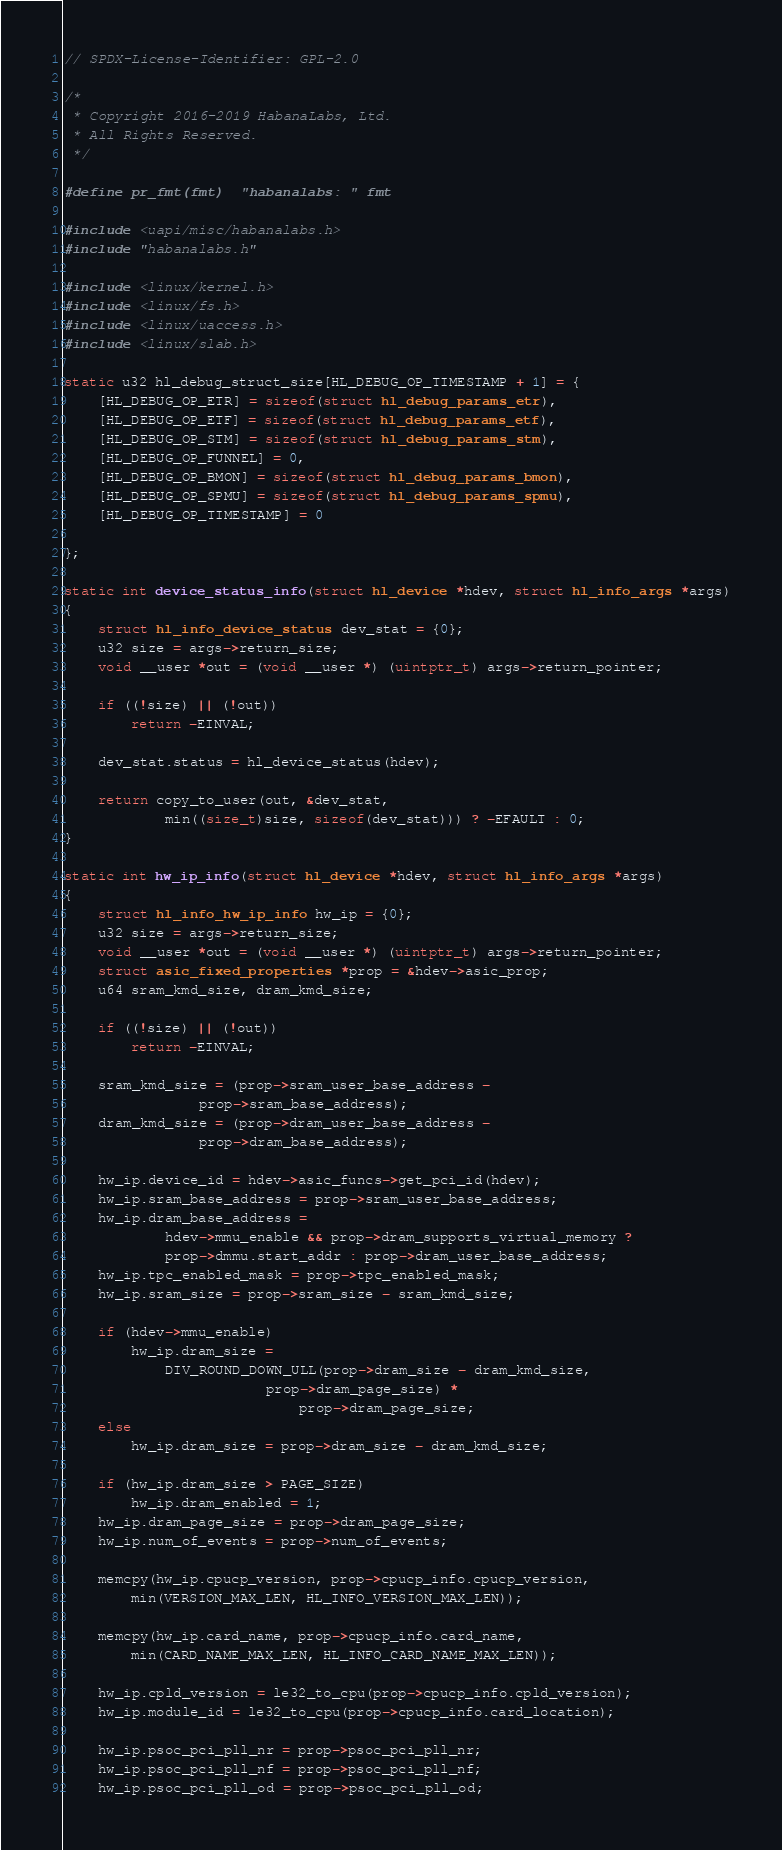<code> <loc_0><loc_0><loc_500><loc_500><_C_>// SPDX-License-Identifier: GPL-2.0

/*
 * Copyright 2016-2019 HabanaLabs, Ltd.
 * All Rights Reserved.
 */

#define pr_fmt(fmt)	"habanalabs: " fmt

#include <uapi/misc/habanalabs.h>
#include "habanalabs.h"

#include <linux/kernel.h>
#include <linux/fs.h>
#include <linux/uaccess.h>
#include <linux/slab.h>

static u32 hl_debug_struct_size[HL_DEBUG_OP_TIMESTAMP + 1] = {
	[HL_DEBUG_OP_ETR] = sizeof(struct hl_debug_params_etr),
	[HL_DEBUG_OP_ETF] = sizeof(struct hl_debug_params_etf),
	[HL_DEBUG_OP_STM] = sizeof(struct hl_debug_params_stm),
	[HL_DEBUG_OP_FUNNEL] = 0,
	[HL_DEBUG_OP_BMON] = sizeof(struct hl_debug_params_bmon),
	[HL_DEBUG_OP_SPMU] = sizeof(struct hl_debug_params_spmu),
	[HL_DEBUG_OP_TIMESTAMP] = 0

};

static int device_status_info(struct hl_device *hdev, struct hl_info_args *args)
{
	struct hl_info_device_status dev_stat = {0};
	u32 size = args->return_size;
	void __user *out = (void __user *) (uintptr_t) args->return_pointer;

	if ((!size) || (!out))
		return -EINVAL;

	dev_stat.status = hl_device_status(hdev);

	return copy_to_user(out, &dev_stat,
			min((size_t)size, sizeof(dev_stat))) ? -EFAULT : 0;
}

static int hw_ip_info(struct hl_device *hdev, struct hl_info_args *args)
{
	struct hl_info_hw_ip_info hw_ip = {0};
	u32 size = args->return_size;
	void __user *out = (void __user *) (uintptr_t) args->return_pointer;
	struct asic_fixed_properties *prop = &hdev->asic_prop;
	u64 sram_kmd_size, dram_kmd_size;

	if ((!size) || (!out))
		return -EINVAL;

	sram_kmd_size = (prop->sram_user_base_address -
				prop->sram_base_address);
	dram_kmd_size = (prop->dram_user_base_address -
				prop->dram_base_address);

	hw_ip.device_id = hdev->asic_funcs->get_pci_id(hdev);
	hw_ip.sram_base_address = prop->sram_user_base_address;
	hw_ip.dram_base_address =
			hdev->mmu_enable && prop->dram_supports_virtual_memory ?
			prop->dmmu.start_addr : prop->dram_user_base_address;
	hw_ip.tpc_enabled_mask = prop->tpc_enabled_mask;
	hw_ip.sram_size = prop->sram_size - sram_kmd_size;

	if (hdev->mmu_enable)
		hw_ip.dram_size =
			DIV_ROUND_DOWN_ULL(prop->dram_size - dram_kmd_size,
						prop->dram_page_size) *
							prop->dram_page_size;
	else
		hw_ip.dram_size = prop->dram_size - dram_kmd_size;

	if (hw_ip.dram_size > PAGE_SIZE)
		hw_ip.dram_enabled = 1;
	hw_ip.dram_page_size = prop->dram_page_size;
	hw_ip.num_of_events = prop->num_of_events;

	memcpy(hw_ip.cpucp_version, prop->cpucp_info.cpucp_version,
		min(VERSION_MAX_LEN, HL_INFO_VERSION_MAX_LEN));

	memcpy(hw_ip.card_name, prop->cpucp_info.card_name,
		min(CARD_NAME_MAX_LEN, HL_INFO_CARD_NAME_MAX_LEN));

	hw_ip.cpld_version = le32_to_cpu(prop->cpucp_info.cpld_version);
	hw_ip.module_id = le32_to_cpu(prop->cpucp_info.card_location);

	hw_ip.psoc_pci_pll_nr = prop->psoc_pci_pll_nr;
	hw_ip.psoc_pci_pll_nf = prop->psoc_pci_pll_nf;
	hw_ip.psoc_pci_pll_od = prop->psoc_pci_pll_od;</code> 